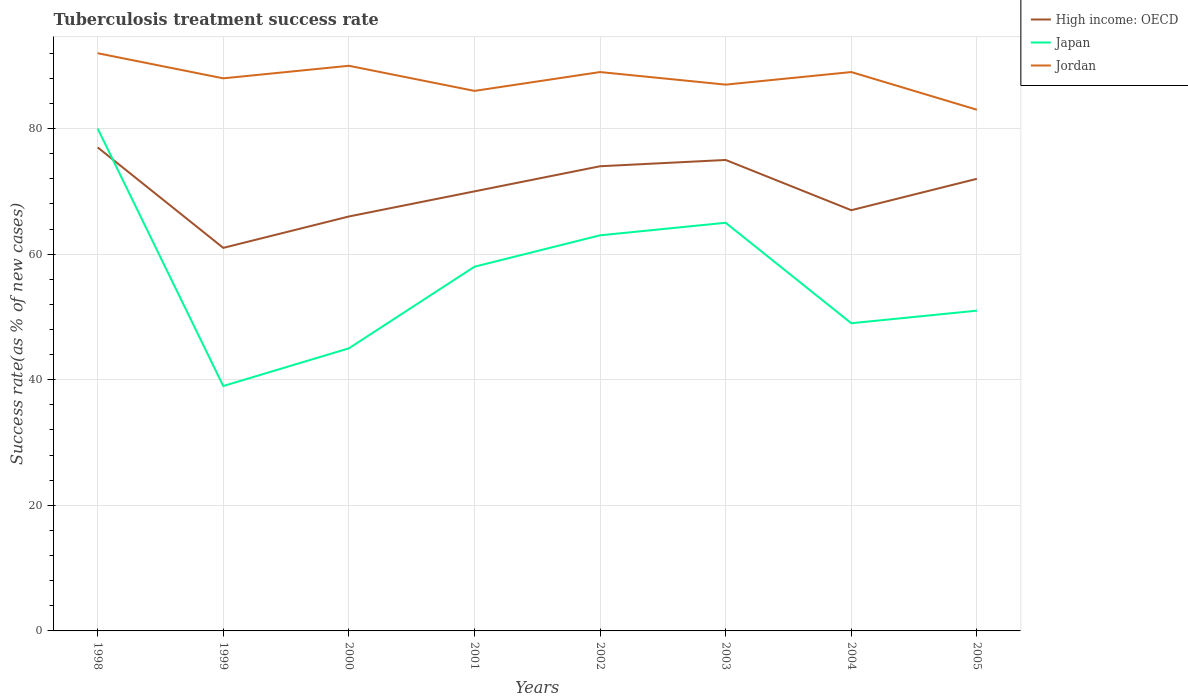Does the line corresponding to High income: OECD intersect with the line corresponding to Jordan?
Offer a terse response. No. In which year was the tuberculosis treatment success rate in Japan maximum?
Provide a short and direct response. 1999. What is the total tuberculosis treatment success rate in Jordan in the graph?
Your answer should be compact. -2. Where does the legend appear in the graph?
Make the answer very short. Top right. How are the legend labels stacked?
Offer a very short reply. Vertical. What is the title of the graph?
Offer a very short reply. Tuberculosis treatment success rate. Does "Cayman Islands" appear as one of the legend labels in the graph?
Make the answer very short. No. What is the label or title of the X-axis?
Ensure brevity in your answer.  Years. What is the label or title of the Y-axis?
Provide a short and direct response. Success rate(as % of new cases). What is the Success rate(as % of new cases) of Japan in 1998?
Offer a terse response. 80. What is the Success rate(as % of new cases) of Jordan in 1998?
Provide a succinct answer. 92. What is the Success rate(as % of new cases) in High income: OECD in 1999?
Make the answer very short. 61. What is the Success rate(as % of new cases) in Jordan in 1999?
Make the answer very short. 88. What is the Success rate(as % of new cases) in Japan in 2000?
Ensure brevity in your answer.  45. What is the Success rate(as % of new cases) in High income: OECD in 2001?
Your response must be concise. 70. What is the Success rate(as % of new cases) in Japan in 2001?
Give a very brief answer. 58. What is the Success rate(as % of new cases) in Jordan in 2001?
Provide a short and direct response. 86. What is the Success rate(as % of new cases) in High income: OECD in 2002?
Your answer should be compact. 74. What is the Success rate(as % of new cases) in Jordan in 2002?
Your answer should be compact. 89. What is the Success rate(as % of new cases) in Japan in 2003?
Your response must be concise. 65. What is the Success rate(as % of new cases) of Jordan in 2003?
Ensure brevity in your answer.  87. What is the Success rate(as % of new cases) in Jordan in 2004?
Ensure brevity in your answer.  89. What is the Success rate(as % of new cases) of Japan in 2005?
Your answer should be very brief. 51. Across all years, what is the maximum Success rate(as % of new cases) in Jordan?
Offer a very short reply. 92. Across all years, what is the minimum Success rate(as % of new cases) in High income: OECD?
Your response must be concise. 61. Across all years, what is the minimum Success rate(as % of new cases) in Jordan?
Your answer should be compact. 83. What is the total Success rate(as % of new cases) of High income: OECD in the graph?
Your response must be concise. 562. What is the total Success rate(as % of new cases) in Japan in the graph?
Give a very brief answer. 450. What is the total Success rate(as % of new cases) in Jordan in the graph?
Offer a terse response. 704. What is the difference between the Success rate(as % of new cases) of High income: OECD in 1998 and that in 1999?
Keep it short and to the point. 16. What is the difference between the Success rate(as % of new cases) in Japan in 1998 and that in 1999?
Your answer should be compact. 41. What is the difference between the Success rate(as % of new cases) in Jordan in 1998 and that in 1999?
Make the answer very short. 4. What is the difference between the Success rate(as % of new cases) in Japan in 1998 and that in 2000?
Your answer should be very brief. 35. What is the difference between the Success rate(as % of new cases) of Japan in 1998 and that in 2002?
Offer a terse response. 17. What is the difference between the Success rate(as % of new cases) in Jordan in 1998 and that in 2003?
Your answer should be compact. 5. What is the difference between the Success rate(as % of new cases) of High income: OECD in 1998 and that in 2004?
Provide a short and direct response. 10. What is the difference between the Success rate(as % of new cases) of High income: OECD in 1998 and that in 2005?
Provide a short and direct response. 5. What is the difference between the Success rate(as % of new cases) of Japan in 1998 and that in 2005?
Your answer should be very brief. 29. What is the difference between the Success rate(as % of new cases) of Jordan in 1998 and that in 2005?
Provide a succinct answer. 9. What is the difference between the Success rate(as % of new cases) of Jordan in 1999 and that in 2000?
Keep it short and to the point. -2. What is the difference between the Success rate(as % of new cases) in High income: OECD in 1999 and that in 2001?
Ensure brevity in your answer.  -9. What is the difference between the Success rate(as % of new cases) in Japan in 1999 and that in 2001?
Give a very brief answer. -19. What is the difference between the Success rate(as % of new cases) in Jordan in 1999 and that in 2002?
Your response must be concise. -1. What is the difference between the Success rate(as % of new cases) of Japan in 1999 and that in 2003?
Offer a terse response. -26. What is the difference between the Success rate(as % of new cases) of High income: OECD in 1999 and that in 2004?
Offer a terse response. -6. What is the difference between the Success rate(as % of new cases) in Japan in 1999 and that in 2004?
Make the answer very short. -10. What is the difference between the Success rate(as % of new cases) in Jordan in 1999 and that in 2004?
Make the answer very short. -1. What is the difference between the Success rate(as % of new cases) of High income: OECD in 2000 and that in 2001?
Offer a terse response. -4. What is the difference between the Success rate(as % of new cases) of Jordan in 2000 and that in 2002?
Make the answer very short. 1. What is the difference between the Success rate(as % of new cases) of High income: OECD in 2000 and that in 2004?
Make the answer very short. -1. What is the difference between the Success rate(as % of new cases) of Jordan in 2000 and that in 2004?
Your response must be concise. 1. What is the difference between the Success rate(as % of new cases) in High income: OECD in 2000 and that in 2005?
Provide a succinct answer. -6. What is the difference between the Success rate(as % of new cases) of High income: OECD in 2001 and that in 2002?
Make the answer very short. -4. What is the difference between the Success rate(as % of new cases) of Japan in 2001 and that in 2003?
Your answer should be compact. -7. What is the difference between the Success rate(as % of new cases) of Jordan in 2001 and that in 2003?
Provide a short and direct response. -1. What is the difference between the Success rate(as % of new cases) of High income: OECD in 2001 and that in 2004?
Offer a terse response. 3. What is the difference between the Success rate(as % of new cases) of Japan in 2001 and that in 2005?
Make the answer very short. 7. What is the difference between the Success rate(as % of new cases) of Jordan in 2001 and that in 2005?
Your answer should be compact. 3. What is the difference between the Success rate(as % of new cases) in High income: OECD in 2002 and that in 2004?
Ensure brevity in your answer.  7. What is the difference between the Success rate(as % of new cases) of Japan in 2002 and that in 2005?
Offer a terse response. 12. What is the difference between the Success rate(as % of new cases) of High income: OECD in 2003 and that in 2004?
Provide a short and direct response. 8. What is the difference between the Success rate(as % of new cases) in Japan in 2003 and that in 2004?
Your answer should be very brief. 16. What is the difference between the Success rate(as % of new cases) of High income: OECD in 2003 and that in 2005?
Your answer should be compact. 3. What is the difference between the Success rate(as % of new cases) of Japan in 2003 and that in 2005?
Give a very brief answer. 14. What is the difference between the Success rate(as % of new cases) in Jordan in 2004 and that in 2005?
Offer a very short reply. 6. What is the difference between the Success rate(as % of new cases) in High income: OECD in 1998 and the Success rate(as % of new cases) in Japan in 1999?
Make the answer very short. 38. What is the difference between the Success rate(as % of new cases) of Japan in 1998 and the Success rate(as % of new cases) of Jordan in 1999?
Make the answer very short. -8. What is the difference between the Success rate(as % of new cases) in High income: OECD in 1998 and the Success rate(as % of new cases) in Jordan in 2000?
Offer a very short reply. -13. What is the difference between the Success rate(as % of new cases) in High income: OECD in 1998 and the Success rate(as % of new cases) in Japan in 2001?
Give a very brief answer. 19. What is the difference between the Success rate(as % of new cases) of High income: OECD in 1998 and the Success rate(as % of new cases) of Jordan in 2001?
Ensure brevity in your answer.  -9. What is the difference between the Success rate(as % of new cases) of Japan in 1998 and the Success rate(as % of new cases) of Jordan in 2003?
Your answer should be compact. -7. What is the difference between the Success rate(as % of new cases) of High income: OECD in 1998 and the Success rate(as % of new cases) of Jordan in 2005?
Give a very brief answer. -6. What is the difference between the Success rate(as % of new cases) in High income: OECD in 1999 and the Success rate(as % of new cases) in Jordan in 2000?
Make the answer very short. -29. What is the difference between the Success rate(as % of new cases) of Japan in 1999 and the Success rate(as % of new cases) of Jordan in 2000?
Your answer should be compact. -51. What is the difference between the Success rate(as % of new cases) in Japan in 1999 and the Success rate(as % of new cases) in Jordan in 2001?
Provide a short and direct response. -47. What is the difference between the Success rate(as % of new cases) in High income: OECD in 1999 and the Success rate(as % of new cases) in Jordan in 2002?
Your answer should be very brief. -28. What is the difference between the Success rate(as % of new cases) of Japan in 1999 and the Success rate(as % of new cases) of Jordan in 2002?
Ensure brevity in your answer.  -50. What is the difference between the Success rate(as % of new cases) in High income: OECD in 1999 and the Success rate(as % of new cases) in Jordan in 2003?
Provide a succinct answer. -26. What is the difference between the Success rate(as % of new cases) of Japan in 1999 and the Success rate(as % of new cases) of Jordan in 2003?
Provide a short and direct response. -48. What is the difference between the Success rate(as % of new cases) of High income: OECD in 1999 and the Success rate(as % of new cases) of Japan in 2004?
Make the answer very short. 12. What is the difference between the Success rate(as % of new cases) in High income: OECD in 1999 and the Success rate(as % of new cases) in Jordan in 2004?
Keep it short and to the point. -28. What is the difference between the Success rate(as % of new cases) in Japan in 1999 and the Success rate(as % of new cases) in Jordan in 2005?
Ensure brevity in your answer.  -44. What is the difference between the Success rate(as % of new cases) in High income: OECD in 2000 and the Success rate(as % of new cases) in Japan in 2001?
Your response must be concise. 8. What is the difference between the Success rate(as % of new cases) in High income: OECD in 2000 and the Success rate(as % of new cases) in Jordan in 2001?
Offer a very short reply. -20. What is the difference between the Success rate(as % of new cases) in Japan in 2000 and the Success rate(as % of new cases) in Jordan in 2001?
Your answer should be compact. -41. What is the difference between the Success rate(as % of new cases) of High income: OECD in 2000 and the Success rate(as % of new cases) of Jordan in 2002?
Make the answer very short. -23. What is the difference between the Success rate(as % of new cases) in Japan in 2000 and the Success rate(as % of new cases) in Jordan in 2002?
Keep it short and to the point. -44. What is the difference between the Success rate(as % of new cases) in High income: OECD in 2000 and the Success rate(as % of new cases) in Japan in 2003?
Keep it short and to the point. 1. What is the difference between the Success rate(as % of new cases) of Japan in 2000 and the Success rate(as % of new cases) of Jordan in 2003?
Provide a short and direct response. -42. What is the difference between the Success rate(as % of new cases) of Japan in 2000 and the Success rate(as % of new cases) of Jordan in 2004?
Provide a short and direct response. -44. What is the difference between the Success rate(as % of new cases) in High income: OECD in 2000 and the Success rate(as % of new cases) in Japan in 2005?
Your response must be concise. 15. What is the difference between the Success rate(as % of new cases) in High income: OECD in 2000 and the Success rate(as % of new cases) in Jordan in 2005?
Make the answer very short. -17. What is the difference between the Success rate(as % of new cases) of Japan in 2000 and the Success rate(as % of new cases) of Jordan in 2005?
Your response must be concise. -38. What is the difference between the Success rate(as % of new cases) of High income: OECD in 2001 and the Success rate(as % of new cases) of Japan in 2002?
Make the answer very short. 7. What is the difference between the Success rate(as % of new cases) of High income: OECD in 2001 and the Success rate(as % of new cases) of Jordan in 2002?
Keep it short and to the point. -19. What is the difference between the Success rate(as % of new cases) of Japan in 2001 and the Success rate(as % of new cases) of Jordan in 2002?
Ensure brevity in your answer.  -31. What is the difference between the Success rate(as % of new cases) of Japan in 2001 and the Success rate(as % of new cases) of Jordan in 2003?
Make the answer very short. -29. What is the difference between the Success rate(as % of new cases) in High income: OECD in 2001 and the Success rate(as % of new cases) in Jordan in 2004?
Provide a short and direct response. -19. What is the difference between the Success rate(as % of new cases) in Japan in 2001 and the Success rate(as % of new cases) in Jordan in 2004?
Give a very brief answer. -31. What is the difference between the Success rate(as % of new cases) of High income: OECD in 2001 and the Success rate(as % of new cases) of Jordan in 2005?
Ensure brevity in your answer.  -13. What is the difference between the Success rate(as % of new cases) in Japan in 2001 and the Success rate(as % of new cases) in Jordan in 2005?
Give a very brief answer. -25. What is the difference between the Success rate(as % of new cases) in Japan in 2002 and the Success rate(as % of new cases) in Jordan in 2003?
Offer a terse response. -24. What is the difference between the Success rate(as % of new cases) in High income: OECD in 2002 and the Success rate(as % of new cases) in Japan in 2004?
Give a very brief answer. 25. What is the difference between the Success rate(as % of new cases) of Japan in 2002 and the Success rate(as % of new cases) of Jordan in 2004?
Give a very brief answer. -26. What is the difference between the Success rate(as % of new cases) in Japan in 2002 and the Success rate(as % of new cases) in Jordan in 2005?
Make the answer very short. -20. What is the difference between the Success rate(as % of new cases) in High income: OECD in 2003 and the Success rate(as % of new cases) in Japan in 2005?
Give a very brief answer. 24. What is the difference between the Success rate(as % of new cases) in High income: OECD in 2003 and the Success rate(as % of new cases) in Jordan in 2005?
Make the answer very short. -8. What is the difference between the Success rate(as % of new cases) of Japan in 2003 and the Success rate(as % of new cases) of Jordan in 2005?
Offer a terse response. -18. What is the difference between the Success rate(as % of new cases) of High income: OECD in 2004 and the Success rate(as % of new cases) of Jordan in 2005?
Keep it short and to the point. -16. What is the difference between the Success rate(as % of new cases) of Japan in 2004 and the Success rate(as % of new cases) of Jordan in 2005?
Give a very brief answer. -34. What is the average Success rate(as % of new cases) of High income: OECD per year?
Your answer should be compact. 70.25. What is the average Success rate(as % of new cases) in Japan per year?
Offer a very short reply. 56.25. What is the average Success rate(as % of new cases) in Jordan per year?
Make the answer very short. 88. In the year 1998, what is the difference between the Success rate(as % of new cases) in High income: OECD and Success rate(as % of new cases) in Jordan?
Make the answer very short. -15. In the year 1998, what is the difference between the Success rate(as % of new cases) of Japan and Success rate(as % of new cases) of Jordan?
Make the answer very short. -12. In the year 1999, what is the difference between the Success rate(as % of new cases) in Japan and Success rate(as % of new cases) in Jordan?
Give a very brief answer. -49. In the year 2000, what is the difference between the Success rate(as % of new cases) of High income: OECD and Success rate(as % of new cases) of Japan?
Provide a short and direct response. 21. In the year 2000, what is the difference between the Success rate(as % of new cases) of High income: OECD and Success rate(as % of new cases) of Jordan?
Ensure brevity in your answer.  -24. In the year 2000, what is the difference between the Success rate(as % of new cases) in Japan and Success rate(as % of new cases) in Jordan?
Provide a succinct answer. -45. In the year 2001, what is the difference between the Success rate(as % of new cases) in High income: OECD and Success rate(as % of new cases) in Jordan?
Keep it short and to the point. -16. In the year 2002, what is the difference between the Success rate(as % of new cases) of High income: OECD and Success rate(as % of new cases) of Japan?
Your answer should be compact. 11. In the year 2003, what is the difference between the Success rate(as % of new cases) in High income: OECD and Success rate(as % of new cases) in Japan?
Your answer should be compact. 10. In the year 2003, what is the difference between the Success rate(as % of new cases) in High income: OECD and Success rate(as % of new cases) in Jordan?
Provide a succinct answer. -12. In the year 2003, what is the difference between the Success rate(as % of new cases) in Japan and Success rate(as % of new cases) in Jordan?
Offer a very short reply. -22. In the year 2005, what is the difference between the Success rate(as % of new cases) of Japan and Success rate(as % of new cases) of Jordan?
Provide a succinct answer. -32. What is the ratio of the Success rate(as % of new cases) in High income: OECD in 1998 to that in 1999?
Your answer should be very brief. 1.26. What is the ratio of the Success rate(as % of new cases) in Japan in 1998 to that in 1999?
Your answer should be compact. 2.05. What is the ratio of the Success rate(as % of new cases) of Jordan in 1998 to that in 1999?
Offer a very short reply. 1.05. What is the ratio of the Success rate(as % of new cases) in High income: OECD in 1998 to that in 2000?
Offer a terse response. 1.17. What is the ratio of the Success rate(as % of new cases) of Japan in 1998 to that in 2000?
Ensure brevity in your answer.  1.78. What is the ratio of the Success rate(as % of new cases) of Jordan in 1998 to that in 2000?
Ensure brevity in your answer.  1.02. What is the ratio of the Success rate(as % of new cases) in High income: OECD in 1998 to that in 2001?
Your response must be concise. 1.1. What is the ratio of the Success rate(as % of new cases) of Japan in 1998 to that in 2001?
Provide a succinct answer. 1.38. What is the ratio of the Success rate(as % of new cases) of Jordan in 1998 to that in 2001?
Your answer should be very brief. 1.07. What is the ratio of the Success rate(as % of new cases) of High income: OECD in 1998 to that in 2002?
Keep it short and to the point. 1.04. What is the ratio of the Success rate(as % of new cases) of Japan in 1998 to that in 2002?
Your answer should be very brief. 1.27. What is the ratio of the Success rate(as % of new cases) in Jordan in 1998 to that in 2002?
Offer a very short reply. 1.03. What is the ratio of the Success rate(as % of new cases) of High income: OECD in 1998 to that in 2003?
Your answer should be very brief. 1.03. What is the ratio of the Success rate(as % of new cases) of Japan in 1998 to that in 2003?
Make the answer very short. 1.23. What is the ratio of the Success rate(as % of new cases) in Jordan in 1998 to that in 2003?
Give a very brief answer. 1.06. What is the ratio of the Success rate(as % of new cases) in High income: OECD in 1998 to that in 2004?
Your answer should be compact. 1.15. What is the ratio of the Success rate(as % of new cases) of Japan in 1998 to that in 2004?
Offer a very short reply. 1.63. What is the ratio of the Success rate(as % of new cases) in Jordan in 1998 to that in 2004?
Give a very brief answer. 1.03. What is the ratio of the Success rate(as % of new cases) of High income: OECD in 1998 to that in 2005?
Your answer should be compact. 1.07. What is the ratio of the Success rate(as % of new cases) in Japan in 1998 to that in 2005?
Provide a short and direct response. 1.57. What is the ratio of the Success rate(as % of new cases) in Jordan in 1998 to that in 2005?
Your response must be concise. 1.11. What is the ratio of the Success rate(as % of new cases) in High income: OECD in 1999 to that in 2000?
Your response must be concise. 0.92. What is the ratio of the Success rate(as % of new cases) in Japan in 1999 to that in 2000?
Provide a short and direct response. 0.87. What is the ratio of the Success rate(as % of new cases) of Jordan in 1999 to that in 2000?
Provide a succinct answer. 0.98. What is the ratio of the Success rate(as % of new cases) in High income: OECD in 1999 to that in 2001?
Your answer should be compact. 0.87. What is the ratio of the Success rate(as % of new cases) of Japan in 1999 to that in 2001?
Offer a very short reply. 0.67. What is the ratio of the Success rate(as % of new cases) of Jordan in 1999 to that in 2001?
Offer a very short reply. 1.02. What is the ratio of the Success rate(as % of new cases) of High income: OECD in 1999 to that in 2002?
Keep it short and to the point. 0.82. What is the ratio of the Success rate(as % of new cases) of Japan in 1999 to that in 2002?
Your answer should be compact. 0.62. What is the ratio of the Success rate(as % of new cases) in High income: OECD in 1999 to that in 2003?
Your response must be concise. 0.81. What is the ratio of the Success rate(as % of new cases) of Jordan in 1999 to that in 2003?
Your answer should be compact. 1.01. What is the ratio of the Success rate(as % of new cases) in High income: OECD in 1999 to that in 2004?
Offer a very short reply. 0.91. What is the ratio of the Success rate(as % of new cases) in Japan in 1999 to that in 2004?
Make the answer very short. 0.8. What is the ratio of the Success rate(as % of new cases) in Jordan in 1999 to that in 2004?
Your answer should be compact. 0.99. What is the ratio of the Success rate(as % of new cases) in High income: OECD in 1999 to that in 2005?
Offer a very short reply. 0.85. What is the ratio of the Success rate(as % of new cases) of Japan in 1999 to that in 2005?
Your answer should be very brief. 0.76. What is the ratio of the Success rate(as % of new cases) in Jordan in 1999 to that in 2005?
Offer a very short reply. 1.06. What is the ratio of the Success rate(as % of new cases) of High income: OECD in 2000 to that in 2001?
Your answer should be very brief. 0.94. What is the ratio of the Success rate(as % of new cases) of Japan in 2000 to that in 2001?
Provide a short and direct response. 0.78. What is the ratio of the Success rate(as % of new cases) in Jordan in 2000 to that in 2001?
Offer a terse response. 1.05. What is the ratio of the Success rate(as % of new cases) of High income: OECD in 2000 to that in 2002?
Provide a short and direct response. 0.89. What is the ratio of the Success rate(as % of new cases) in Jordan in 2000 to that in 2002?
Provide a succinct answer. 1.01. What is the ratio of the Success rate(as % of new cases) in Japan in 2000 to that in 2003?
Give a very brief answer. 0.69. What is the ratio of the Success rate(as % of new cases) of Jordan in 2000 to that in 2003?
Give a very brief answer. 1.03. What is the ratio of the Success rate(as % of new cases) of High income: OECD in 2000 to that in 2004?
Give a very brief answer. 0.99. What is the ratio of the Success rate(as % of new cases) of Japan in 2000 to that in 2004?
Your answer should be compact. 0.92. What is the ratio of the Success rate(as % of new cases) of Jordan in 2000 to that in 2004?
Your answer should be compact. 1.01. What is the ratio of the Success rate(as % of new cases) in High income: OECD in 2000 to that in 2005?
Make the answer very short. 0.92. What is the ratio of the Success rate(as % of new cases) in Japan in 2000 to that in 2005?
Your answer should be very brief. 0.88. What is the ratio of the Success rate(as % of new cases) in Jordan in 2000 to that in 2005?
Keep it short and to the point. 1.08. What is the ratio of the Success rate(as % of new cases) of High income: OECD in 2001 to that in 2002?
Your response must be concise. 0.95. What is the ratio of the Success rate(as % of new cases) of Japan in 2001 to that in 2002?
Give a very brief answer. 0.92. What is the ratio of the Success rate(as % of new cases) of Jordan in 2001 to that in 2002?
Your answer should be compact. 0.97. What is the ratio of the Success rate(as % of new cases) in Japan in 2001 to that in 2003?
Your answer should be very brief. 0.89. What is the ratio of the Success rate(as % of new cases) of Jordan in 2001 to that in 2003?
Give a very brief answer. 0.99. What is the ratio of the Success rate(as % of new cases) of High income: OECD in 2001 to that in 2004?
Offer a very short reply. 1.04. What is the ratio of the Success rate(as % of new cases) of Japan in 2001 to that in 2004?
Keep it short and to the point. 1.18. What is the ratio of the Success rate(as % of new cases) of Jordan in 2001 to that in 2004?
Your response must be concise. 0.97. What is the ratio of the Success rate(as % of new cases) of High income: OECD in 2001 to that in 2005?
Your answer should be compact. 0.97. What is the ratio of the Success rate(as % of new cases) in Japan in 2001 to that in 2005?
Keep it short and to the point. 1.14. What is the ratio of the Success rate(as % of new cases) in Jordan in 2001 to that in 2005?
Provide a short and direct response. 1.04. What is the ratio of the Success rate(as % of new cases) of High income: OECD in 2002 to that in 2003?
Ensure brevity in your answer.  0.99. What is the ratio of the Success rate(as % of new cases) in Japan in 2002 to that in 2003?
Give a very brief answer. 0.97. What is the ratio of the Success rate(as % of new cases) in High income: OECD in 2002 to that in 2004?
Offer a very short reply. 1.1. What is the ratio of the Success rate(as % of new cases) in Jordan in 2002 to that in 2004?
Provide a succinct answer. 1. What is the ratio of the Success rate(as % of new cases) in High income: OECD in 2002 to that in 2005?
Keep it short and to the point. 1.03. What is the ratio of the Success rate(as % of new cases) of Japan in 2002 to that in 2005?
Ensure brevity in your answer.  1.24. What is the ratio of the Success rate(as % of new cases) of Jordan in 2002 to that in 2005?
Your response must be concise. 1.07. What is the ratio of the Success rate(as % of new cases) of High income: OECD in 2003 to that in 2004?
Give a very brief answer. 1.12. What is the ratio of the Success rate(as % of new cases) in Japan in 2003 to that in 2004?
Provide a short and direct response. 1.33. What is the ratio of the Success rate(as % of new cases) of Jordan in 2003 to that in 2004?
Give a very brief answer. 0.98. What is the ratio of the Success rate(as % of new cases) in High income: OECD in 2003 to that in 2005?
Keep it short and to the point. 1.04. What is the ratio of the Success rate(as % of new cases) of Japan in 2003 to that in 2005?
Your answer should be compact. 1.27. What is the ratio of the Success rate(as % of new cases) of Jordan in 2003 to that in 2005?
Your answer should be very brief. 1.05. What is the ratio of the Success rate(as % of new cases) of High income: OECD in 2004 to that in 2005?
Provide a succinct answer. 0.93. What is the ratio of the Success rate(as % of new cases) of Japan in 2004 to that in 2005?
Offer a terse response. 0.96. What is the ratio of the Success rate(as % of new cases) in Jordan in 2004 to that in 2005?
Offer a terse response. 1.07. What is the difference between the highest and the second highest Success rate(as % of new cases) in High income: OECD?
Provide a short and direct response. 2. What is the difference between the highest and the second highest Success rate(as % of new cases) of Japan?
Give a very brief answer. 15. What is the difference between the highest and the second highest Success rate(as % of new cases) of Jordan?
Provide a succinct answer. 2. What is the difference between the highest and the lowest Success rate(as % of new cases) in Japan?
Offer a very short reply. 41. 